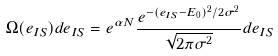Convert formula to latex. <formula><loc_0><loc_0><loc_500><loc_500>\Omega ( e _ { I S } ) d e _ { I S } = e ^ { \alpha N } \frac { e ^ { - ( e _ { I S } - E _ { 0 } ) ^ { 2 } / 2 \sigma ^ { 2 } } } { \sqrt { 2 \pi \sigma ^ { 2 } } } d e _ { I S }</formula> 